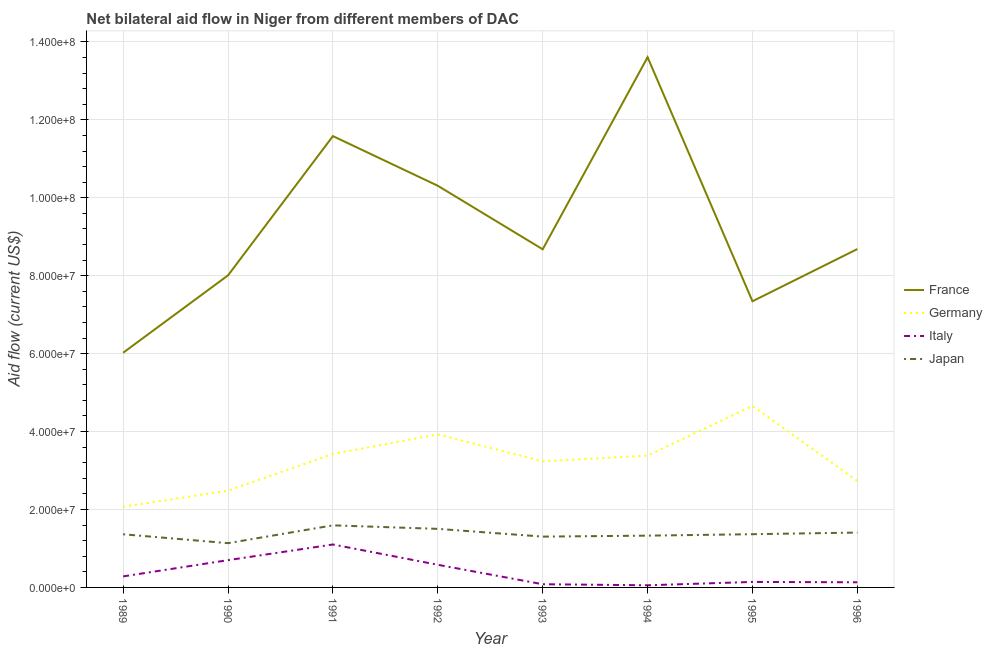Does the line corresponding to amount of aid given by japan intersect with the line corresponding to amount of aid given by france?
Your response must be concise. No. What is the amount of aid given by france in 1995?
Give a very brief answer. 7.34e+07. Across all years, what is the maximum amount of aid given by japan?
Provide a short and direct response. 1.59e+07. Across all years, what is the minimum amount of aid given by france?
Keep it short and to the point. 6.02e+07. In which year was the amount of aid given by france maximum?
Offer a terse response. 1994. What is the total amount of aid given by germany in the graph?
Offer a terse response. 2.59e+08. What is the difference between the amount of aid given by italy in 1989 and that in 1990?
Offer a very short reply. -4.17e+06. What is the difference between the amount of aid given by germany in 1992 and the amount of aid given by france in 1991?
Provide a succinct answer. -7.66e+07. What is the average amount of aid given by france per year?
Give a very brief answer. 9.28e+07. In the year 1992, what is the difference between the amount of aid given by japan and amount of aid given by germany?
Ensure brevity in your answer.  -2.42e+07. In how many years, is the amount of aid given by japan greater than 60000000 US$?
Keep it short and to the point. 0. What is the ratio of the amount of aid given by france in 1989 to that in 1992?
Ensure brevity in your answer.  0.58. Is the amount of aid given by italy in 1992 less than that in 1993?
Give a very brief answer. No. Is the difference between the amount of aid given by japan in 1990 and 1993 greater than the difference between the amount of aid given by germany in 1990 and 1993?
Your answer should be compact. Yes. What is the difference between the highest and the lowest amount of aid given by italy?
Give a very brief answer. 1.05e+07. In how many years, is the amount of aid given by france greater than the average amount of aid given by france taken over all years?
Your answer should be compact. 3. Is the sum of the amount of aid given by france in 1993 and 1996 greater than the maximum amount of aid given by germany across all years?
Give a very brief answer. Yes. Is it the case that in every year, the sum of the amount of aid given by japan and amount of aid given by italy is greater than the sum of amount of aid given by france and amount of aid given by germany?
Your answer should be very brief. No. Is it the case that in every year, the sum of the amount of aid given by france and amount of aid given by germany is greater than the amount of aid given by italy?
Ensure brevity in your answer.  Yes. Is the amount of aid given by france strictly less than the amount of aid given by germany over the years?
Give a very brief answer. No. How many years are there in the graph?
Provide a short and direct response. 8. What is the difference between two consecutive major ticks on the Y-axis?
Your answer should be very brief. 2.00e+07. Are the values on the major ticks of Y-axis written in scientific E-notation?
Your answer should be compact. Yes. Where does the legend appear in the graph?
Provide a succinct answer. Center right. How are the legend labels stacked?
Make the answer very short. Vertical. What is the title of the graph?
Ensure brevity in your answer.  Net bilateral aid flow in Niger from different members of DAC. What is the label or title of the Y-axis?
Your answer should be very brief. Aid flow (current US$). What is the Aid flow (current US$) of France in 1989?
Provide a short and direct response. 6.02e+07. What is the Aid flow (current US$) in Germany in 1989?
Provide a succinct answer. 2.07e+07. What is the Aid flow (current US$) of Italy in 1989?
Provide a succinct answer. 2.83e+06. What is the Aid flow (current US$) of Japan in 1989?
Offer a terse response. 1.36e+07. What is the Aid flow (current US$) in France in 1990?
Your response must be concise. 8.01e+07. What is the Aid flow (current US$) of Germany in 1990?
Keep it short and to the point. 2.48e+07. What is the Aid flow (current US$) of Italy in 1990?
Give a very brief answer. 7.00e+06. What is the Aid flow (current US$) of Japan in 1990?
Make the answer very short. 1.14e+07. What is the Aid flow (current US$) of France in 1991?
Provide a short and direct response. 1.16e+08. What is the Aid flow (current US$) of Germany in 1991?
Offer a very short reply. 3.43e+07. What is the Aid flow (current US$) in Italy in 1991?
Provide a succinct answer. 1.10e+07. What is the Aid flow (current US$) in Japan in 1991?
Offer a very short reply. 1.59e+07. What is the Aid flow (current US$) in France in 1992?
Keep it short and to the point. 1.03e+08. What is the Aid flow (current US$) of Germany in 1992?
Provide a succinct answer. 3.93e+07. What is the Aid flow (current US$) in Italy in 1992?
Give a very brief answer. 5.81e+06. What is the Aid flow (current US$) in Japan in 1992?
Offer a terse response. 1.50e+07. What is the Aid flow (current US$) of France in 1993?
Offer a terse response. 8.68e+07. What is the Aid flow (current US$) of Germany in 1993?
Offer a terse response. 3.24e+07. What is the Aid flow (current US$) of Italy in 1993?
Ensure brevity in your answer.  8.20e+05. What is the Aid flow (current US$) in Japan in 1993?
Offer a terse response. 1.30e+07. What is the Aid flow (current US$) in France in 1994?
Your answer should be very brief. 1.36e+08. What is the Aid flow (current US$) of Germany in 1994?
Keep it short and to the point. 3.38e+07. What is the Aid flow (current US$) in Japan in 1994?
Your response must be concise. 1.33e+07. What is the Aid flow (current US$) in France in 1995?
Ensure brevity in your answer.  7.34e+07. What is the Aid flow (current US$) of Germany in 1995?
Your answer should be very brief. 4.66e+07. What is the Aid flow (current US$) in Italy in 1995?
Your answer should be very brief. 1.41e+06. What is the Aid flow (current US$) in Japan in 1995?
Your response must be concise. 1.37e+07. What is the Aid flow (current US$) in France in 1996?
Provide a short and direct response. 8.68e+07. What is the Aid flow (current US$) of Germany in 1996?
Offer a terse response. 2.73e+07. What is the Aid flow (current US$) in Italy in 1996?
Make the answer very short. 1.32e+06. What is the Aid flow (current US$) of Japan in 1996?
Make the answer very short. 1.41e+07. Across all years, what is the maximum Aid flow (current US$) of France?
Your response must be concise. 1.36e+08. Across all years, what is the maximum Aid flow (current US$) in Germany?
Your answer should be compact. 4.66e+07. Across all years, what is the maximum Aid flow (current US$) in Italy?
Give a very brief answer. 1.10e+07. Across all years, what is the maximum Aid flow (current US$) in Japan?
Your response must be concise. 1.59e+07. Across all years, what is the minimum Aid flow (current US$) in France?
Give a very brief answer. 6.02e+07. Across all years, what is the minimum Aid flow (current US$) of Germany?
Provide a succinct answer. 2.07e+07. Across all years, what is the minimum Aid flow (current US$) of Italy?
Your answer should be compact. 5.50e+05. Across all years, what is the minimum Aid flow (current US$) of Japan?
Keep it short and to the point. 1.14e+07. What is the total Aid flow (current US$) of France in the graph?
Your answer should be very brief. 7.42e+08. What is the total Aid flow (current US$) of Germany in the graph?
Make the answer very short. 2.59e+08. What is the total Aid flow (current US$) of Italy in the graph?
Your answer should be very brief. 3.08e+07. What is the total Aid flow (current US$) of Japan in the graph?
Your response must be concise. 1.10e+08. What is the difference between the Aid flow (current US$) in France in 1989 and that in 1990?
Provide a succinct answer. -1.99e+07. What is the difference between the Aid flow (current US$) in Germany in 1989 and that in 1990?
Your response must be concise. -4.14e+06. What is the difference between the Aid flow (current US$) in Italy in 1989 and that in 1990?
Offer a terse response. -4.17e+06. What is the difference between the Aid flow (current US$) of Japan in 1989 and that in 1990?
Ensure brevity in your answer.  2.28e+06. What is the difference between the Aid flow (current US$) of France in 1989 and that in 1991?
Your answer should be compact. -5.56e+07. What is the difference between the Aid flow (current US$) of Germany in 1989 and that in 1991?
Ensure brevity in your answer.  -1.36e+07. What is the difference between the Aid flow (current US$) of Italy in 1989 and that in 1991?
Give a very brief answer. -8.19e+06. What is the difference between the Aid flow (current US$) in Japan in 1989 and that in 1991?
Keep it short and to the point. -2.29e+06. What is the difference between the Aid flow (current US$) in France in 1989 and that in 1992?
Your answer should be very brief. -4.28e+07. What is the difference between the Aid flow (current US$) in Germany in 1989 and that in 1992?
Offer a terse response. -1.86e+07. What is the difference between the Aid flow (current US$) in Italy in 1989 and that in 1992?
Your answer should be very brief. -2.98e+06. What is the difference between the Aid flow (current US$) of Japan in 1989 and that in 1992?
Offer a very short reply. -1.39e+06. What is the difference between the Aid flow (current US$) in France in 1989 and that in 1993?
Your response must be concise. -2.66e+07. What is the difference between the Aid flow (current US$) of Germany in 1989 and that in 1993?
Make the answer very short. -1.17e+07. What is the difference between the Aid flow (current US$) in Italy in 1989 and that in 1993?
Offer a very short reply. 2.01e+06. What is the difference between the Aid flow (current US$) of Japan in 1989 and that in 1993?
Provide a short and direct response. 6.00e+05. What is the difference between the Aid flow (current US$) in France in 1989 and that in 1994?
Offer a very short reply. -7.58e+07. What is the difference between the Aid flow (current US$) in Germany in 1989 and that in 1994?
Your response must be concise. -1.31e+07. What is the difference between the Aid flow (current US$) of Italy in 1989 and that in 1994?
Make the answer very short. 2.28e+06. What is the difference between the Aid flow (current US$) in Japan in 1989 and that in 1994?
Your answer should be compact. 3.50e+05. What is the difference between the Aid flow (current US$) in France in 1989 and that in 1995?
Keep it short and to the point. -1.32e+07. What is the difference between the Aid flow (current US$) in Germany in 1989 and that in 1995?
Give a very brief answer. -2.59e+07. What is the difference between the Aid flow (current US$) of Italy in 1989 and that in 1995?
Give a very brief answer. 1.42e+06. What is the difference between the Aid flow (current US$) in Japan in 1989 and that in 1995?
Provide a short and direct response. -2.00e+04. What is the difference between the Aid flow (current US$) of France in 1989 and that in 1996?
Keep it short and to the point. -2.66e+07. What is the difference between the Aid flow (current US$) in Germany in 1989 and that in 1996?
Offer a terse response. -6.61e+06. What is the difference between the Aid flow (current US$) of Italy in 1989 and that in 1996?
Offer a very short reply. 1.51e+06. What is the difference between the Aid flow (current US$) in Japan in 1989 and that in 1996?
Provide a succinct answer. -4.40e+05. What is the difference between the Aid flow (current US$) of France in 1990 and that in 1991?
Ensure brevity in your answer.  -3.57e+07. What is the difference between the Aid flow (current US$) of Germany in 1990 and that in 1991?
Provide a succinct answer. -9.42e+06. What is the difference between the Aid flow (current US$) in Italy in 1990 and that in 1991?
Provide a succinct answer. -4.02e+06. What is the difference between the Aid flow (current US$) of Japan in 1990 and that in 1991?
Provide a succinct answer. -4.57e+06. What is the difference between the Aid flow (current US$) of France in 1990 and that in 1992?
Give a very brief answer. -2.30e+07. What is the difference between the Aid flow (current US$) in Germany in 1990 and that in 1992?
Keep it short and to the point. -1.44e+07. What is the difference between the Aid flow (current US$) of Italy in 1990 and that in 1992?
Your answer should be very brief. 1.19e+06. What is the difference between the Aid flow (current US$) of Japan in 1990 and that in 1992?
Provide a short and direct response. -3.67e+06. What is the difference between the Aid flow (current US$) in France in 1990 and that in 1993?
Make the answer very short. -6.69e+06. What is the difference between the Aid flow (current US$) in Germany in 1990 and that in 1993?
Your answer should be compact. -7.53e+06. What is the difference between the Aid flow (current US$) of Italy in 1990 and that in 1993?
Your answer should be very brief. 6.18e+06. What is the difference between the Aid flow (current US$) in Japan in 1990 and that in 1993?
Provide a succinct answer. -1.68e+06. What is the difference between the Aid flow (current US$) of France in 1990 and that in 1994?
Provide a succinct answer. -5.60e+07. What is the difference between the Aid flow (current US$) of Germany in 1990 and that in 1994?
Offer a terse response. -8.99e+06. What is the difference between the Aid flow (current US$) in Italy in 1990 and that in 1994?
Your response must be concise. 6.45e+06. What is the difference between the Aid flow (current US$) in Japan in 1990 and that in 1994?
Ensure brevity in your answer.  -1.93e+06. What is the difference between the Aid flow (current US$) of France in 1990 and that in 1995?
Offer a very short reply. 6.65e+06. What is the difference between the Aid flow (current US$) in Germany in 1990 and that in 1995?
Keep it short and to the point. -2.17e+07. What is the difference between the Aid flow (current US$) of Italy in 1990 and that in 1995?
Make the answer very short. 5.59e+06. What is the difference between the Aid flow (current US$) in Japan in 1990 and that in 1995?
Give a very brief answer. -2.30e+06. What is the difference between the Aid flow (current US$) in France in 1990 and that in 1996?
Offer a very short reply. -6.75e+06. What is the difference between the Aid flow (current US$) in Germany in 1990 and that in 1996?
Offer a terse response. -2.47e+06. What is the difference between the Aid flow (current US$) in Italy in 1990 and that in 1996?
Make the answer very short. 5.68e+06. What is the difference between the Aid flow (current US$) in Japan in 1990 and that in 1996?
Offer a very short reply. -2.72e+06. What is the difference between the Aid flow (current US$) in France in 1991 and that in 1992?
Provide a short and direct response. 1.28e+07. What is the difference between the Aid flow (current US$) of Germany in 1991 and that in 1992?
Your answer should be very brief. -5.01e+06. What is the difference between the Aid flow (current US$) of Italy in 1991 and that in 1992?
Your answer should be compact. 5.21e+06. What is the difference between the Aid flow (current US$) of France in 1991 and that in 1993?
Make the answer very short. 2.90e+07. What is the difference between the Aid flow (current US$) of Germany in 1991 and that in 1993?
Provide a short and direct response. 1.89e+06. What is the difference between the Aid flow (current US$) in Italy in 1991 and that in 1993?
Offer a terse response. 1.02e+07. What is the difference between the Aid flow (current US$) in Japan in 1991 and that in 1993?
Your response must be concise. 2.89e+06. What is the difference between the Aid flow (current US$) in France in 1991 and that in 1994?
Offer a terse response. -2.02e+07. What is the difference between the Aid flow (current US$) in Italy in 1991 and that in 1994?
Give a very brief answer. 1.05e+07. What is the difference between the Aid flow (current US$) of Japan in 1991 and that in 1994?
Make the answer very short. 2.64e+06. What is the difference between the Aid flow (current US$) in France in 1991 and that in 1995?
Offer a terse response. 4.24e+07. What is the difference between the Aid flow (current US$) of Germany in 1991 and that in 1995?
Your answer should be compact. -1.23e+07. What is the difference between the Aid flow (current US$) in Italy in 1991 and that in 1995?
Provide a short and direct response. 9.61e+06. What is the difference between the Aid flow (current US$) in Japan in 1991 and that in 1995?
Offer a very short reply. 2.27e+06. What is the difference between the Aid flow (current US$) of France in 1991 and that in 1996?
Your answer should be very brief. 2.90e+07. What is the difference between the Aid flow (current US$) of Germany in 1991 and that in 1996?
Provide a succinct answer. 6.95e+06. What is the difference between the Aid flow (current US$) of Italy in 1991 and that in 1996?
Keep it short and to the point. 9.70e+06. What is the difference between the Aid flow (current US$) of Japan in 1991 and that in 1996?
Make the answer very short. 1.85e+06. What is the difference between the Aid flow (current US$) in France in 1992 and that in 1993?
Your answer should be very brief. 1.63e+07. What is the difference between the Aid flow (current US$) of Germany in 1992 and that in 1993?
Your answer should be compact. 6.90e+06. What is the difference between the Aid flow (current US$) of Italy in 1992 and that in 1993?
Keep it short and to the point. 4.99e+06. What is the difference between the Aid flow (current US$) of Japan in 1992 and that in 1993?
Your response must be concise. 1.99e+06. What is the difference between the Aid flow (current US$) in France in 1992 and that in 1994?
Ensure brevity in your answer.  -3.30e+07. What is the difference between the Aid flow (current US$) in Germany in 1992 and that in 1994?
Your answer should be compact. 5.44e+06. What is the difference between the Aid flow (current US$) of Italy in 1992 and that in 1994?
Give a very brief answer. 5.26e+06. What is the difference between the Aid flow (current US$) of Japan in 1992 and that in 1994?
Ensure brevity in your answer.  1.74e+06. What is the difference between the Aid flow (current US$) of France in 1992 and that in 1995?
Offer a terse response. 2.96e+07. What is the difference between the Aid flow (current US$) in Germany in 1992 and that in 1995?
Your answer should be compact. -7.31e+06. What is the difference between the Aid flow (current US$) in Italy in 1992 and that in 1995?
Offer a very short reply. 4.40e+06. What is the difference between the Aid flow (current US$) of Japan in 1992 and that in 1995?
Your response must be concise. 1.37e+06. What is the difference between the Aid flow (current US$) in France in 1992 and that in 1996?
Offer a very short reply. 1.62e+07. What is the difference between the Aid flow (current US$) of Germany in 1992 and that in 1996?
Your response must be concise. 1.20e+07. What is the difference between the Aid flow (current US$) of Italy in 1992 and that in 1996?
Provide a short and direct response. 4.49e+06. What is the difference between the Aid flow (current US$) of Japan in 1992 and that in 1996?
Give a very brief answer. 9.50e+05. What is the difference between the Aid flow (current US$) in France in 1993 and that in 1994?
Provide a succinct answer. -4.93e+07. What is the difference between the Aid flow (current US$) of Germany in 1993 and that in 1994?
Your answer should be compact. -1.46e+06. What is the difference between the Aid flow (current US$) of Italy in 1993 and that in 1994?
Your response must be concise. 2.70e+05. What is the difference between the Aid flow (current US$) in Japan in 1993 and that in 1994?
Your response must be concise. -2.50e+05. What is the difference between the Aid flow (current US$) of France in 1993 and that in 1995?
Provide a succinct answer. 1.33e+07. What is the difference between the Aid flow (current US$) of Germany in 1993 and that in 1995?
Provide a short and direct response. -1.42e+07. What is the difference between the Aid flow (current US$) of Italy in 1993 and that in 1995?
Provide a short and direct response. -5.90e+05. What is the difference between the Aid flow (current US$) of Japan in 1993 and that in 1995?
Provide a short and direct response. -6.20e+05. What is the difference between the Aid flow (current US$) in Germany in 1993 and that in 1996?
Provide a short and direct response. 5.06e+06. What is the difference between the Aid flow (current US$) of Italy in 1993 and that in 1996?
Offer a terse response. -5.00e+05. What is the difference between the Aid flow (current US$) of Japan in 1993 and that in 1996?
Provide a short and direct response. -1.04e+06. What is the difference between the Aid flow (current US$) in France in 1994 and that in 1995?
Your response must be concise. 6.26e+07. What is the difference between the Aid flow (current US$) of Germany in 1994 and that in 1995?
Keep it short and to the point. -1.28e+07. What is the difference between the Aid flow (current US$) in Italy in 1994 and that in 1995?
Give a very brief answer. -8.60e+05. What is the difference between the Aid flow (current US$) in Japan in 1994 and that in 1995?
Your answer should be very brief. -3.70e+05. What is the difference between the Aid flow (current US$) of France in 1994 and that in 1996?
Keep it short and to the point. 4.92e+07. What is the difference between the Aid flow (current US$) in Germany in 1994 and that in 1996?
Keep it short and to the point. 6.52e+06. What is the difference between the Aid flow (current US$) of Italy in 1994 and that in 1996?
Keep it short and to the point. -7.70e+05. What is the difference between the Aid flow (current US$) of Japan in 1994 and that in 1996?
Provide a succinct answer. -7.90e+05. What is the difference between the Aid flow (current US$) of France in 1995 and that in 1996?
Give a very brief answer. -1.34e+07. What is the difference between the Aid flow (current US$) in Germany in 1995 and that in 1996?
Offer a very short reply. 1.93e+07. What is the difference between the Aid flow (current US$) in Italy in 1995 and that in 1996?
Your answer should be very brief. 9.00e+04. What is the difference between the Aid flow (current US$) in Japan in 1995 and that in 1996?
Offer a terse response. -4.20e+05. What is the difference between the Aid flow (current US$) in France in 1989 and the Aid flow (current US$) in Germany in 1990?
Offer a very short reply. 3.54e+07. What is the difference between the Aid flow (current US$) in France in 1989 and the Aid flow (current US$) in Italy in 1990?
Your answer should be very brief. 5.32e+07. What is the difference between the Aid flow (current US$) in France in 1989 and the Aid flow (current US$) in Japan in 1990?
Ensure brevity in your answer.  4.89e+07. What is the difference between the Aid flow (current US$) in Germany in 1989 and the Aid flow (current US$) in Italy in 1990?
Ensure brevity in your answer.  1.37e+07. What is the difference between the Aid flow (current US$) of Germany in 1989 and the Aid flow (current US$) of Japan in 1990?
Your response must be concise. 9.34e+06. What is the difference between the Aid flow (current US$) in Italy in 1989 and the Aid flow (current US$) in Japan in 1990?
Give a very brief answer. -8.53e+06. What is the difference between the Aid flow (current US$) of France in 1989 and the Aid flow (current US$) of Germany in 1991?
Offer a terse response. 2.60e+07. What is the difference between the Aid flow (current US$) in France in 1989 and the Aid flow (current US$) in Italy in 1991?
Ensure brevity in your answer.  4.92e+07. What is the difference between the Aid flow (current US$) of France in 1989 and the Aid flow (current US$) of Japan in 1991?
Your answer should be very brief. 4.43e+07. What is the difference between the Aid flow (current US$) in Germany in 1989 and the Aid flow (current US$) in Italy in 1991?
Give a very brief answer. 9.68e+06. What is the difference between the Aid flow (current US$) of Germany in 1989 and the Aid flow (current US$) of Japan in 1991?
Provide a succinct answer. 4.77e+06. What is the difference between the Aid flow (current US$) of Italy in 1989 and the Aid flow (current US$) of Japan in 1991?
Offer a very short reply. -1.31e+07. What is the difference between the Aid flow (current US$) of France in 1989 and the Aid flow (current US$) of Germany in 1992?
Keep it short and to the point. 2.10e+07. What is the difference between the Aid flow (current US$) in France in 1989 and the Aid flow (current US$) in Italy in 1992?
Provide a short and direct response. 5.44e+07. What is the difference between the Aid flow (current US$) of France in 1989 and the Aid flow (current US$) of Japan in 1992?
Your response must be concise. 4.52e+07. What is the difference between the Aid flow (current US$) of Germany in 1989 and the Aid flow (current US$) of Italy in 1992?
Ensure brevity in your answer.  1.49e+07. What is the difference between the Aid flow (current US$) of Germany in 1989 and the Aid flow (current US$) of Japan in 1992?
Give a very brief answer. 5.67e+06. What is the difference between the Aid flow (current US$) of Italy in 1989 and the Aid flow (current US$) of Japan in 1992?
Make the answer very short. -1.22e+07. What is the difference between the Aid flow (current US$) of France in 1989 and the Aid flow (current US$) of Germany in 1993?
Your response must be concise. 2.79e+07. What is the difference between the Aid flow (current US$) of France in 1989 and the Aid flow (current US$) of Italy in 1993?
Your answer should be compact. 5.94e+07. What is the difference between the Aid flow (current US$) in France in 1989 and the Aid flow (current US$) in Japan in 1993?
Offer a terse response. 4.72e+07. What is the difference between the Aid flow (current US$) in Germany in 1989 and the Aid flow (current US$) in Italy in 1993?
Your response must be concise. 1.99e+07. What is the difference between the Aid flow (current US$) in Germany in 1989 and the Aid flow (current US$) in Japan in 1993?
Your response must be concise. 7.66e+06. What is the difference between the Aid flow (current US$) in Italy in 1989 and the Aid flow (current US$) in Japan in 1993?
Your response must be concise. -1.02e+07. What is the difference between the Aid flow (current US$) in France in 1989 and the Aid flow (current US$) in Germany in 1994?
Your answer should be very brief. 2.64e+07. What is the difference between the Aid flow (current US$) in France in 1989 and the Aid flow (current US$) in Italy in 1994?
Your answer should be very brief. 5.97e+07. What is the difference between the Aid flow (current US$) of France in 1989 and the Aid flow (current US$) of Japan in 1994?
Offer a terse response. 4.69e+07. What is the difference between the Aid flow (current US$) of Germany in 1989 and the Aid flow (current US$) of Italy in 1994?
Your answer should be very brief. 2.02e+07. What is the difference between the Aid flow (current US$) of Germany in 1989 and the Aid flow (current US$) of Japan in 1994?
Your response must be concise. 7.41e+06. What is the difference between the Aid flow (current US$) in Italy in 1989 and the Aid flow (current US$) in Japan in 1994?
Your response must be concise. -1.05e+07. What is the difference between the Aid flow (current US$) of France in 1989 and the Aid flow (current US$) of Germany in 1995?
Provide a succinct answer. 1.36e+07. What is the difference between the Aid flow (current US$) of France in 1989 and the Aid flow (current US$) of Italy in 1995?
Ensure brevity in your answer.  5.88e+07. What is the difference between the Aid flow (current US$) of France in 1989 and the Aid flow (current US$) of Japan in 1995?
Keep it short and to the point. 4.66e+07. What is the difference between the Aid flow (current US$) of Germany in 1989 and the Aid flow (current US$) of Italy in 1995?
Give a very brief answer. 1.93e+07. What is the difference between the Aid flow (current US$) of Germany in 1989 and the Aid flow (current US$) of Japan in 1995?
Offer a terse response. 7.04e+06. What is the difference between the Aid flow (current US$) of Italy in 1989 and the Aid flow (current US$) of Japan in 1995?
Ensure brevity in your answer.  -1.08e+07. What is the difference between the Aid flow (current US$) of France in 1989 and the Aid flow (current US$) of Germany in 1996?
Make the answer very short. 3.29e+07. What is the difference between the Aid flow (current US$) in France in 1989 and the Aid flow (current US$) in Italy in 1996?
Offer a very short reply. 5.89e+07. What is the difference between the Aid flow (current US$) of France in 1989 and the Aid flow (current US$) of Japan in 1996?
Give a very brief answer. 4.62e+07. What is the difference between the Aid flow (current US$) in Germany in 1989 and the Aid flow (current US$) in Italy in 1996?
Your answer should be compact. 1.94e+07. What is the difference between the Aid flow (current US$) of Germany in 1989 and the Aid flow (current US$) of Japan in 1996?
Provide a short and direct response. 6.62e+06. What is the difference between the Aid flow (current US$) in Italy in 1989 and the Aid flow (current US$) in Japan in 1996?
Your response must be concise. -1.12e+07. What is the difference between the Aid flow (current US$) of France in 1990 and the Aid flow (current US$) of Germany in 1991?
Ensure brevity in your answer.  4.58e+07. What is the difference between the Aid flow (current US$) of France in 1990 and the Aid flow (current US$) of Italy in 1991?
Make the answer very short. 6.91e+07. What is the difference between the Aid flow (current US$) in France in 1990 and the Aid flow (current US$) in Japan in 1991?
Your answer should be compact. 6.42e+07. What is the difference between the Aid flow (current US$) in Germany in 1990 and the Aid flow (current US$) in Italy in 1991?
Your response must be concise. 1.38e+07. What is the difference between the Aid flow (current US$) of Germany in 1990 and the Aid flow (current US$) of Japan in 1991?
Keep it short and to the point. 8.91e+06. What is the difference between the Aid flow (current US$) in Italy in 1990 and the Aid flow (current US$) in Japan in 1991?
Your response must be concise. -8.93e+06. What is the difference between the Aid flow (current US$) in France in 1990 and the Aid flow (current US$) in Germany in 1992?
Keep it short and to the point. 4.08e+07. What is the difference between the Aid flow (current US$) in France in 1990 and the Aid flow (current US$) in Italy in 1992?
Offer a very short reply. 7.43e+07. What is the difference between the Aid flow (current US$) in France in 1990 and the Aid flow (current US$) in Japan in 1992?
Make the answer very short. 6.51e+07. What is the difference between the Aid flow (current US$) in Germany in 1990 and the Aid flow (current US$) in Italy in 1992?
Your response must be concise. 1.90e+07. What is the difference between the Aid flow (current US$) in Germany in 1990 and the Aid flow (current US$) in Japan in 1992?
Ensure brevity in your answer.  9.81e+06. What is the difference between the Aid flow (current US$) of Italy in 1990 and the Aid flow (current US$) of Japan in 1992?
Keep it short and to the point. -8.03e+06. What is the difference between the Aid flow (current US$) in France in 1990 and the Aid flow (current US$) in Germany in 1993?
Offer a very short reply. 4.77e+07. What is the difference between the Aid flow (current US$) of France in 1990 and the Aid flow (current US$) of Italy in 1993?
Ensure brevity in your answer.  7.93e+07. What is the difference between the Aid flow (current US$) in France in 1990 and the Aid flow (current US$) in Japan in 1993?
Your answer should be very brief. 6.70e+07. What is the difference between the Aid flow (current US$) in Germany in 1990 and the Aid flow (current US$) in Italy in 1993?
Offer a very short reply. 2.40e+07. What is the difference between the Aid flow (current US$) in Germany in 1990 and the Aid flow (current US$) in Japan in 1993?
Offer a terse response. 1.18e+07. What is the difference between the Aid flow (current US$) in Italy in 1990 and the Aid flow (current US$) in Japan in 1993?
Provide a succinct answer. -6.04e+06. What is the difference between the Aid flow (current US$) of France in 1990 and the Aid flow (current US$) of Germany in 1994?
Ensure brevity in your answer.  4.63e+07. What is the difference between the Aid flow (current US$) of France in 1990 and the Aid flow (current US$) of Italy in 1994?
Provide a succinct answer. 7.95e+07. What is the difference between the Aid flow (current US$) in France in 1990 and the Aid flow (current US$) in Japan in 1994?
Provide a succinct answer. 6.68e+07. What is the difference between the Aid flow (current US$) in Germany in 1990 and the Aid flow (current US$) in Italy in 1994?
Your answer should be compact. 2.43e+07. What is the difference between the Aid flow (current US$) in Germany in 1990 and the Aid flow (current US$) in Japan in 1994?
Provide a succinct answer. 1.16e+07. What is the difference between the Aid flow (current US$) in Italy in 1990 and the Aid flow (current US$) in Japan in 1994?
Provide a succinct answer. -6.29e+06. What is the difference between the Aid flow (current US$) of France in 1990 and the Aid flow (current US$) of Germany in 1995?
Give a very brief answer. 3.35e+07. What is the difference between the Aid flow (current US$) in France in 1990 and the Aid flow (current US$) in Italy in 1995?
Provide a short and direct response. 7.87e+07. What is the difference between the Aid flow (current US$) of France in 1990 and the Aid flow (current US$) of Japan in 1995?
Your answer should be compact. 6.64e+07. What is the difference between the Aid flow (current US$) of Germany in 1990 and the Aid flow (current US$) of Italy in 1995?
Your response must be concise. 2.34e+07. What is the difference between the Aid flow (current US$) in Germany in 1990 and the Aid flow (current US$) in Japan in 1995?
Your answer should be very brief. 1.12e+07. What is the difference between the Aid flow (current US$) in Italy in 1990 and the Aid flow (current US$) in Japan in 1995?
Ensure brevity in your answer.  -6.66e+06. What is the difference between the Aid flow (current US$) of France in 1990 and the Aid flow (current US$) of Germany in 1996?
Provide a succinct answer. 5.28e+07. What is the difference between the Aid flow (current US$) of France in 1990 and the Aid flow (current US$) of Italy in 1996?
Offer a very short reply. 7.88e+07. What is the difference between the Aid flow (current US$) of France in 1990 and the Aid flow (current US$) of Japan in 1996?
Give a very brief answer. 6.60e+07. What is the difference between the Aid flow (current US$) of Germany in 1990 and the Aid flow (current US$) of Italy in 1996?
Provide a succinct answer. 2.35e+07. What is the difference between the Aid flow (current US$) in Germany in 1990 and the Aid flow (current US$) in Japan in 1996?
Your answer should be compact. 1.08e+07. What is the difference between the Aid flow (current US$) in Italy in 1990 and the Aid flow (current US$) in Japan in 1996?
Give a very brief answer. -7.08e+06. What is the difference between the Aid flow (current US$) of France in 1991 and the Aid flow (current US$) of Germany in 1992?
Your answer should be compact. 7.66e+07. What is the difference between the Aid flow (current US$) of France in 1991 and the Aid flow (current US$) of Italy in 1992?
Offer a very short reply. 1.10e+08. What is the difference between the Aid flow (current US$) of France in 1991 and the Aid flow (current US$) of Japan in 1992?
Provide a succinct answer. 1.01e+08. What is the difference between the Aid flow (current US$) in Germany in 1991 and the Aid flow (current US$) in Italy in 1992?
Keep it short and to the point. 2.84e+07. What is the difference between the Aid flow (current US$) in Germany in 1991 and the Aid flow (current US$) in Japan in 1992?
Keep it short and to the point. 1.92e+07. What is the difference between the Aid flow (current US$) of Italy in 1991 and the Aid flow (current US$) of Japan in 1992?
Offer a terse response. -4.01e+06. What is the difference between the Aid flow (current US$) in France in 1991 and the Aid flow (current US$) in Germany in 1993?
Your answer should be compact. 8.35e+07. What is the difference between the Aid flow (current US$) of France in 1991 and the Aid flow (current US$) of Italy in 1993?
Offer a terse response. 1.15e+08. What is the difference between the Aid flow (current US$) of France in 1991 and the Aid flow (current US$) of Japan in 1993?
Ensure brevity in your answer.  1.03e+08. What is the difference between the Aid flow (current US$) of Germany in 1991 and the Aid flow (current US$) of Italy in 1993?
Your answer should be very brief. 3.34e+07. What is the difference between the Aid flow (current US$) in Germany in 1991 and the Aid flow (current US$) in Japan in 1993?
Provide a succinct answer. 2.12e+07. What is the difference between the Aid flow (current US$) in Italy in 1991 and the Aid flow (current US$) in Japan in 1993?
Your answer should be compact. -2.02e+06. What is the difference between the Aid flow (current US$) of France in 1991 and the Aid flow (current US$) of Germany in 1994?
Ensure brevity in your answer.  8.20e+07. What is the difference between the Aid flow (current US$) of France in 1991 and the Aid flow (current US$) of Italy in 1994?
Make the answer very short. 1.15e+08. What is the difference between the Aid flow (current US$) of France in 1991 and the Aid flow (current US$) of Japan in 1994?
Offer a very short reply. 1.03e+08. What is the difference between the Aid flow (current US$) of Germany in 1991 and the Aid flow (current US$) of Italy in 1994?
Provide a short and direct response. 3.37e+07. What is the difference between the Aid flow (current US$) of Germany in 1991 and the Aid flow (current US$) of Japan in 1994?
Your answer should be compact. 2.10e+07. What is the difference between the Aid flow (current US$) in Italy in 1991 and the Aid flow (current US$) in Japan in 1994?
Keep it short and to the point. -2.27e+06. What is the difference between the Aid flow (current US$) in France in 1991 and the Aid flow (current US$) in Germany in 1995?
Keep it short and to the point. 6.92e+07. What is the difference between the Aid flow (current US$) in France in 1991 and the Aid flow (current US$) in Italy in 1995?
Ensure brevity in your answer.  1.14e+08. What is the difference between the Aid flow (current US$) of France in 1991 and the Aid flow (current US$) of Japan in 1995?
Provide a succinct answer. 1.02e+08. What is the difference between the Aid flow (current US$) in Germany in 1991 and the Aid flow (current US$) in Italy in 1995?
Offer a very short reply. 3.28e+07. What is the difference between the Aid flow (current US$) of Germany in 1991 and the Aid flow (current US$) of Japan in 1995?
Make the answer very short. 2.06e+07. What is the difference between the Aid flow (current US$) in Italy in 1991 and the Aid flow (current US$) in Japan in 1995?
Offer a terse response. -2.64e+06. What is the difference between the Aid flow (current US$) of France in 1991 and the Aid flow (current US$) of Germany in 1996?
Give a very brief answer. 8.85e+07. What is the difference between the Aid flow (current US$) of France in 1991 and the Aid flow (current US$) of Italy in 1996?
Give a very brief answer. 1.15e+08. What is the difference between the Aid flow (current US$) of France in 1991 and the Aid flow (current US$) of Japan in 1996?
Provide a succinct answer. 1.02e+08. What is the difference between the Aid flow (current US$) in Germany in 1991 and the Aid flow (current US$) in Italy in 1996?
Ensure brevity in your answer.  3.29e+07. What is the difference between the Aid flow (current US$) in Germany in 1991 and the Aid flow (current US$) in Japan in 1996?
Offer a very short reply. 2.02e+07. What is the difference between the Aid flow (current US$) of Italy in 1991 and the Aid flow (current US$) of Japan in 1996?
Provide a succinct answer. -3.06e+06. What is the difference between the Aid flow (current US$) in France in 1992 and the Aid flow (current US$) in Germany in 1993?
Your answer should be very brief. 7.07e+07. What is the difference between the Aid flow (current US$) of France in 1992 and the Aid flow (current US$) of Italy in 1993?
Offer a very short reply. 1.02e+08. What is the difference between the Aid flow (current US$) of France in 1992 and the Aid flow (current US$) of Japan in 1993?
Your answer should be very brief. 9.00e+07. What is the difference between the Aid flow (current US$) in Germany in 1992 and the Aid flow (current US$) in Italy in 1993?
Your answer should be compact. 3.84e+07. What is the difference between the Aid flow (current US$) in Germany in 1992 and the Aid flow (current US$) in Japan in 1993?
Ensure brevity in your answer.  2.62e+07. What is the difference between the Aid flow (current US$) in Italy in 1992 and the Aid flow (current US$) in Japan in 1993?
Make the answer very short. -7.23e+06. What is the difference between the Aid flow (current US$) in France in 1992 and the Aid flow (current US$) in Germany in 1994?
Make the answer very short. 6.92e+07. What is the difference between the Aid flow (current US$) of France in 1992 and the Aid flow (current US$) of Italy in 1994?
Offer a very short reply. 1.03e+08. What is the difference between the Aid flow (current US$) in France in 1992 and the Aid flow (current US$) in Japan in 1994?
Your answer should be compact. 8.98e+07. What is the difference between the Aid flow (current US$) in Germany in 1992 and the Aid flow (current US$) in Italy in 1994?
Your response must be concise. 3.87e+07. What is the difference between the Aid flow (current US$) in Germany in 1992 and the Aid flow (current US$) in Japan in 1994?
Provide a short and direct response. 2.60e+07. What is the difference between the Aid flow (current US$) in Italy in 1992 and the Aid flow (current US$) in Japan in 1994?
Your answer should be very brief. -7.48e+06. What is the difference between the Aid flow (current US$) in France in 1992 and the Aid flow (current US$) in Germany in 1995?
Give a very brief answer. 5.65e+07. What is the difference between the Aid flow (current US$) of France in 1992 and the Aid flow (current US$) of Italy in 1995?
Offer a terse response. 1.02e+08. What is the difference between the Aid flow (current US$) in France in 1992 and the Aid flow (current US$) in Japan in 1995?
Keep it short and to the point. 8.94e+07. What is the difference between the Aid flow (current US$) of Germany in 1992 and the Aid flow (current US$) of Italy in 1995?
Offer a very short reply. 3.79e+07. What is the difference between the Aid flow (current US$) in Germany in 1992 and the Aid flow (current US$) in Japan in 1995?
Give a very brief answer. 2.56e+07. What is the difference between the Aid flow (current US$) in Italy in 1992 and the Aid flow (current US$) in Japan in 1995?
Your answer should be compact. -7.85e+06. What is the difference between the Aid flow (current US$) in France in 1992 and the Aid flow (current US$) in Germany in 1996?
Ensure brevity in your answer.  7.58e+07. What is the difference between the Aid flow (current US$) of France in 1992 and the Aid flow (current US$) of Italy in 1996?
Offer a very short reply. 1.02e+08. What is the difference between the Aid flow (current US$) of France in 1992 and the Aid flow (current US$) of Japan in 1996?
Ensure brevity in your answer.  8.90e+07. What is the difference between the Aid flow (current US$) in Germany in 1992 and the Aid flow (current US$) in Italy in 1996?
Give a very brief answer. 3.80e+07. What is the difference between the Aid flow (current US$) of Germany in 1992 and the Aid flow (current US$) of Japan in 1996?
Ensure brevity in your answer.  2.52e+07. What is the difference between the Aid flow (current US$) in Italy in 1992 and the Aid flow (current US$) in Japan in 1996?
Provide a short and direct response. -8.27e+06. What is the difference between the Aid flow (current US$) in France in 1993 and the Aid flow (current US$) in Germany in 1994?
Provide a short and direct response. 5.30e+07. What is the difference between the Aid flow (current US$) in France in 1993 and the Aid flow (current US$) in Italy in 1994?
Your response must be concise. 8.62e+07. What is the difference between the Aid flow (current US$) in France in 1993 and the Aid flow (current US$) in Japan in 1994?
Your answer should be compact. 7.35e+07. What is the difference between the Aid flow (current US$) in Germany in 1993 and the Aid flow (current US$) in Italy in 1994?
Offer a terse response. 3.18e+07. What is the difference between the Aid flow (current US$) of Germany in 1993 and the Aid flow (current US$) of Japan in 1994?
Offer a terse response. 1.91e+07. What is the difference between the Aid flow (current US$) in Italy in 1993 and the Aid flow (current US$) in Japan in 1994?
Offer a terse response. -1.25e+07. What is the difference between the Aid flow (current US$) of France in 1993 and the Aid flow (current US$) of Germany in 1995?
Keep it short and to the point. 4.02e+07. What is the difference between the Aid flow (current US$) of France in 1993 and the Aid flow (current US$) of Italy in 1995?
Your answer should be compact. 8.54e+07. What is the difference between the Aid flow (current US$) in France in 1993 and the Aid flow (current US$) in Japan in 1995?
Ensure brevity in your answer.  7.31e+07. What is the difference between the Aid flow (current US$) in Germany in 1993 and the Aid flow (current US$) in Italy in 1995?
Ensure brevity in your answer.  3.10e+07. What is the difference between the Aid flow (current US$) in Germany in 1993 and the Aid flow (current US$) in Japan in 1995?
Ensure brevity in your answer.  1.87e+07. What is the difference between the Aid flow (current US$) in Italy in 1993 and the Aid flow (current US$) in Japan in 1995?
Offer a very short reply. -1.28e+07. What is the difference between the Aid flow (current US$) of France in 1993 and the Aid flow (current US$) of Germany in 1996?
Offer a very short reply. 5.95e+07. What is the difference between the Aid flow (current US$) of France in 1993 and the Aid flow (current US$) of Italy in 1996?
Make the answer very short. 8.55e+07. What is the difference between the Aid flow (current US$) in France in 1993 and the Aid flow (current US$) in Japan in 1996?
Your response must be concise. 7.27e+07. What is the difference between the Aid flow (current US$) of Germany in 1993 and the Aid flow (current US$) of Italy in 1996?
Offer a terse response. 3.10e+07. What is the difference between the Aid flow (current US$) of Germany in 1993 and the Aid flow (current US$) of Japan in 1996?
Keep it short and to the point. 1.83e+07. What is the difference between the Aid flow (current US$) in Italy in 1993 and the Aid flow (current US$) in Japan in 1996?
Give a very brief answer. -1.33e+07. What is the difference between the Aid flow (current US$) in France in 1994 and the Aid flow (current US$) in Germany in 1995?
Your answer should be very brief. 8.95e+07. What is the difference between the Aid flow (current US$) of France in 1994 and the Aid flow (current US$) of Italy in 1995?
Provide a short and direct response. 1.35e+08. What is the difference between the Aid flow (current US$) in France in 1994 and the Aid flow (current US$) in Japan in 1995?
Your answer should be very brief. 1.22e+08. What is the difference between the Aid flow (current US$) of Germany in 1994 and the Aid flow (current US$) of Italy in 1995?
Offer a terse response. 3.24e+07. What is the difference between the Aid flow (current US$) in Germany in 1994 and the Aid flow (current US$) in Japan in 1995?
Your answer should be compact. 2.02e+07. What is the difference between the Aid flow (current US$) of Italy in 1994 and the Aid flow (current US$) of Japan in 1995?
Give a very brief answer. -1.31e+07. What is the difference between the Aid flow (current US$) of France in 1994 and the Aid flow (current US$) of Germany in 1996?
Ensure brevity in your answer.  1.09e+08. What is the difference between the Aid flow (current US$) of France in 1994 and the Aid flow (current US$) of Italy in 1996?
Your response must be concise. 1.35e+08. What is the difference between the Aid flow (current US$) in France in 1994 and the Aid flow (current US$) in Japan in 1996?
Your response must be concise. 1.22e+08. What is the difference between the Aid flow (current US$) of Germany in 1994 and the Aid flow (current US$) of Italy in 1996?
Provide a short and direct response. 3.25e+07. What is the difference between the Aid flow (current US$) of Germany in 1994 and the Aid flow (current US$) of Japan in 1996?
Ensure brevity in your answer.  1.98e+07. What is the difference between the Aid flow (current US$) in Italy in 1994 and the Aid flow (current US$) in Japan in 1996?
Ensure brevity in your answer.  -1.35e+07. What is the difference between the Aid flow (current US$) in France in 1995 and the Aid flow (current US$) in Germany in 1996?
Ensure brevity in your answer.  4.61e+07. What is the difference between the Aid flow (current US$) in France in 1995 and the Aid flow (current US$) in Italy in 1996?
Make the answer very short. 7.21e+07. What is the difference between the Aid flow (current US$) of France in 1995 and the Aid flow (current US$) of Japan in 1996?
Provide a succinct answer. 5.94e+07. What is the difference between the Aid flow (current US$) in Germany in 1995 and the Aid flow (current US$) in Italy in 1996?
Offer a very short reply. 4.53e+07. What is the difference between the Aid flow (current US$) in Germany in 1995 and the Aid flow (current US$) in Japan in 1996?
Provide a succinct answer. 3.25e+07. What is the difference between the Aid flow (current US$) of Italy in 1995 and the Aid flow (current US$) of Japan in 1996?
Give a very brief answer. -1.27e+07. What is the average Aid flow (current US$) in France per year?
Your response must be concise. 9.28e+07. What is the average Aid flow (current US$) in Germany per year?
Make the answer very short. 3.24e+07. What is the average Aid flow (current US$) in Italy per year?
Offer a terse response. 3.84e+06. What is the average Aid flow (current US$) in Japan per year?
Give a very brief answer. 1.38e+07. In the year 1989, what is the difference between the Aid flow (current US$) in France and Aid flow (current US$) in Germany?
Ensure brevity in your answer.  3.95e+07. In the year 1989, what is the difference between the Aid flow (current US$) in France and Aid flow (current US$) in Italy?
Your response must be concise. 5.74e+07. In the year 1989, what is the difference between the Aid flow (current US$) in France and Aid flow (current US$) in Japan?
Your answer should be compact. 4.66e+07. In the year 1989, what is the difference between the Aid flow (current US$) in Germany and Aid flow (current US$) in Italy?
Make the answer very short. 1.79e+07. In the year 1989, what is the difference between the Aid flow (current US$) in Germany and Aid flow (current US$) in Japan?
Make the answer very short. 7.06e+06. In the year 1989, what is the difference between the Aid flow (current US$) of Italy and Aid flow (current US$) of Japan?
Make the answer very short. -1.08e+07. In the year 1990, what is the difference between the Aid flow (current US$) of France and Aid flow (current US$) of Germany?
Give a very brief answer. 5.52e+07. In the year 1990, what is the difference between the Aid flow (current US$) of France and Aid flow (current US$) of Italy?
Offer a very short reply. 7.31e+07. In the year 1990, what is the difference between the Aid flow (current US$) in France and Aid flow (current US$) in Japan?
Ensure brevity in your answer.  6.87e+07. In the year 1990, what is the difference between the Aid flow (current US$) of Germany and Aid flow (current US$) of Italy?
Provide a succinct answer. 1.78e+07. In the year 1990, what is the difference between the Aid flow (current US$) of Germany and Aid flow (current US$) of Japan?
Provide a succinct answer. 1.35e+07. In the year 1990, what is the difference between the Aid flow (current US$) in Italy and Aid flow (current US$) in Japan?
Give a very brief answer. -4.36e+06. In the year 1991, what is the difference between the Aid flow (current US$) in France and Aid flow (current US$) in Germany?
Your answer should be very brief. 8.16e+07. In the year 1991, what is the difference between the Aid flow (current US$) in France and Aid flow (current US$) in Italy?
Your response must be concise. 1.05e+08. In the year 1991, what is the difference between the Aid flow (current US$) in France and Aid flow (current US$) in Japan?
Keep it short and to the point. 9.99e+07. In the year 1991, what is the difference between the Aid flow (current US$) in Germany and Aid flow (current US$) in Italy?
Give a very brief answer. 2.32e+07. In the year 1991, what is the difference between the Aid flow (current US$) of Germany and Aid flow (current US$) of Japan?
Your response must be concise. 1.83e+07. In the year 1991, what is the difference between the Aid flow (current US$) in Italy and Aid flow (current US$) in Japan?
Ensure brevity in your answer.  -4.91e+06. In the year 1992, what is the difference between the Aid flow (current US$) in France and Aid flow (current US$) in Germany?
Offer a very short reply. 6.38e+07. In the year 1992, what is the difference between the Aid flow (current US$) in France and Aid flow (current US$) in Italy?
Keep it short and to the point. 9.73e+07. In the year 1992, what is the difference between the Aid flow (current US$) in France and Aid flow (current US$) in Japan?
Provide a succinct answer. 8.80e+07. In the year 1992, what is the difference between the Aid flow (current US$) in Germany and Aid flow (current US$) in Italy?
Ensure brevity in your answer.  3.35e+07. In the year 1992, what is the difference between the Aid flow (current US$) in Germany and Aid flow (current US$) in Japan?
Provide a succinct answer. 2.42e+07. In the year 1992, what is the difference between the Aid flow (current US$) of Italy and Aid flow (current US$) of Japan?
Provide a succinct answer. -9.22e+06. In the year 1993, what is the difference between the Aid flow (current US$) in France and Aid flow (current US$) in Germany?
Keep it short and to the point. 5.44e+07. In the year 1993, what is the difference between the Aid flow (current US$) of France and Aid flow (current US$) of Italy?
Offer a very short reply. 8.60e+07. In the year 1993, what is the difference between the Aid flow (current US$) in France and Aid flow (current US$) in Japan?
Your answer should be very brief. 7.37e+07. In the year 1993, what is the difference between the Aid flow (current US$) in Germany and Aid flow (current US$) in Italy?
Keep it short and to the point. 3.16e+07. In the year 1993, what is the difference between the Aid flow (current US$) in Germany and Aid flow (current US$) in Japan?
Your answer should be very brief. 1.93e+07. In the year 1993, what is the difference between the Aid flow (current US$) of Italy and Aid flow (current US$) of Japan?
Make the answer very short. -1.22e+07. In the year 1994, what is the difference between the Aid flow (current US$) of France and Aid flow (current US$) of Germany?
Your response must be concise. 1.02e+08. In the year 1994, what is the difference between the Aid flow (current US$) of France and Aid flow (current US$) of Italy?
Keep it short and to the point. 1.36e+08. In the year 1994, what is the difference between the Aid flow (current US$) in France and Aid flow (current US$) in Japan?
Ensure brevity in your answer.  1.23e+08. In the year 1994, what is the difference between the Aid flow (current US$) of Germany and Aid flow (current US$) of Italy?
Your response must be concise. 3.33e+07. In the year 1994, what is the difference between the Aid flow (current US$) of Germany and Aid flow (current US$) of Japan?
Your answer should be very brief. 2.05e+07. In the year 1994, what is the difference between the Aid flow (current US$) in Italy and Aid flow (current US$) in Japan?
Provide a short and direct response. -1.27e+07. In the year 1995, what is the difference between the Aid flow (current US$) of France and Aid flow (current US$) of Germany?
Your response must be concise. 2.69e+07. In the year 1995, what is the difference between the Aid flow (current US$) of France and Aid flow (current US$) of Italy?
Make the answer very short. 7.20e+07. In the year 1995, what is the difference between the Aid flow (current US$) of France and Aid flow (current US$) of Japan?
Make the answer very short. 5.98e+07. In the year 1995, what is the difference between the Aid flow (current US$) of Germany and Aid flow (current US$) of Italy?
Your answer should be very brief. 4.52e+07. In the year 1995, what is the difference between the Aid flow (current US$) of Germany and Aid flow (current US$) of Japan?
Give a very brief answer. 3.29e+07. In the year 1995, what is the difference between the Aid flow (current US$) in Italy and Aid flow (current US$) in Japan?
Your answer should be compact. -1.22e+07. In the year 1996, what is the difference between the Aid flow (current US$) of France and Aid flow (current US$) of Germany?
Offer a terse response. 5.95e+07. In the year 1996, what is the difference between the Aid flow (current US$) of France and Aid flow (current US$) of Italy?
Provide a succinct answer. 8.55e+07. In the year 1996, what is the difference between the Aid flow (current US$) of France and Aid flow (current US$) of Japan?
Your response must be concise. 7.28e+07. In the year 1996, what is the difference between the Aid flow (current US$) of Germany and Aid flow (current US$) of Italy?
Keep it short and to the point. 2.60e+07. In the year 1996, what is the difference between the Aid flow (current US$) in Germany and Aid flow (current US$) in Japan?
Offer a terse response. 1.32e+07. In the year 1996, what is the difference between the Aid flow (current US$) in Italy and Aid flow (current US$) in Japan?
Offer a terse response. -1.28e+07. What is the ratio of the Aid flow (current US$) of France in 1989 to that in 1990?
Offer a terse response. 0.75. What is the ratio of the Aid flow (current US$) of Germany in 1989 to that in 1990?
Provide a succinct answer. 0.83. What is the ratio of the Aid flow (current US$) in Italy in 1989 to that in 1990?
Make the answer very short. 0.4. What is the ratio of the Aid flow (current US$) of Japan in 1989 to that in 1990?
Keep it short and to the point. 1.2. What is the ratio of the Aid flow (current US$) of France in 1989 to that in 1991?
Ensure brevity in your answer.  0.52. What is the ratio of the Aid flow (current US$) of Germany in 1989 to that in 1991?
Your answer should be very brief. 0.6. What is the ratio of the Aid flow (current US$) in Italy in 1989 to that in 1991?
Provide a succinct answer. 0.26. What is the ratio of the Aid flow (current US$) of Japan in 1989 to that in 1991?
Offer a very short reply. 0.86. What is the ratio of the Aid flow (current US$) of France in 1989 to that in 1992?
Ensure brevity in your answer.  0.58. What is the ratio of the Aid flow (current US$) of Germany in 1989 to that in 1992?
Provide a succinct answer. 0.53. What is the ratio of the Aid flow (current US$) of Italy in 1989 to that in 1992?
Provide a succinct answer. 0.49. What is the ratio of the Aid flow (current US$) of Japan in 1989 to that in 1992?
Provide a short and direct response. 0.91. What is the ratio of the Aid flow (current US$) in France in 1989 to that in 1993?
Your answer should be very brief. 0.69. What is the ratio of the Aid flow (current US$) in Germany in 1989 to that in 1993?
Offer a terse response. 0.64. What is the ratio of the Aid flow (current US$) of Italy in 1989 to that in 1993?
Keep it short and to the point. 3.45. What is the ratio of the Aid flow (current US$) of Japan in 1989 to that in 1993?
Your answer should be very brief. 1.05. What is the ratio of the Aid flow (current US$) in France in 1989 to that in 1994?
Make the answer very short. 0.44. What is the ratio of the Aid flow (current US$) in Germany in 1989 to that in 1994?
Your response must be concise. 0.61. What is the ratio of the Aid flow (current US$) in Italy in 1989 to that in 1994?
Your answer should be very brief. 5.15. What is the ratio of the Aid flow (current US$) in Japan in 1989 to that in 1994?
Your answer should be very brief. 1.03. What is the ratio of the Aid flow (current US$) of France in 1989 to that in 1995?
Your answer should be compact. 0.82. What is the ratio of the Aid flow (current US$) of Germany in 1989 to that in 1995?
Provide a short and direct response. 0.44. What is the ratio of the Aid flow (current US$) of Italy in 1989 to that in 1995?
Your response must be concise. 2.01. What is the ratio of the Aid flow (current US$) in France in 1989 to that in 1996?
Offer a very short reply. 0.69. What is the ratio of the Aid flow (current US$) in Germany in 1989 to that in 1996?
Your answer should be very brief. 0.76. What is the ratio of the Aid flow (current US$) in Italy in 1989 to that in 1996?
Provide a succinct answer. 2.14. What is the ratio of the Aid flow (current US$) in Japan in 1989 to that in 1996?
Your answer should be compact. 0.97. What is the ratio of the Aid flow (current US$) in France in 1990 to that in 1991?
Your answer should be compact. 0.69. What is the ratio of the Aid flow (current US$) of Germany in 1990 to that in 1991?
Keep it short and to the point. 0.72. What is the ratio of the Aid flow (current US$) of Italy in 1990 to that in 1991?
Keep it short and to the point. 0.64. What is the ratio of the Aid flow (current US$) in Japan in 1990 to that in 1991?
Your answer should be compact. 0.71. What is the ratio of the Aid flow (current US$) in France in 1990 to that in 1992?
Offer a very short reply. 0.78. What is the ratio of the Aid flow (current US$) in Germany in 1990 to that in 1992?
Offer a very short reply. 0.63. What is the ratio of the Aid flow (current US$) of Italy in 1990 to that in 1992?
Offer a terse response. 1.2. What is the ratio of the Aid flow (current US$) of Japan in 1990 to that in 1992?
Keep it short and to the point. 0.76. What is the ratio of the Aid flow (current US$) of France in 1990 to that in 1993?
Offer a very short reply. 0.92. What is the ratio of the Aid flow (current US$) in Germany in 1990 to that in 1993?
Your answer should be very brief. 0.77. What is the ratio of the Aid flow (current US$) in Italy in 1990 to that in 1993?
Offer a very short reply. 8.54. What is the ratio of the Aid flow (current US$) of Japan in 1990 to that in 1993?
Offer a terse response. 0.87. What is the ratio of the Aid flow (current US$) in France in 1990 to that in 1994?
Ensure brevity in your answer.  0.59. What is the ratio of the Aid flow (current US$) in Germany in 1990 to that in 1994?
Provide a succinct answer. 0.73. What is the ratio of the Aid flow (current US$) in Italy in 1990 to that in 1994?
Your answer should be compact. 12.73. What is the ratio of the Aid flow (current US$) of Japan in 1990 to that in 1994?
Your response must be concise. 0.85. What is the ratio of the Aid flow (current US$) of France in 1990 to that in 1995?
Give a very brief answer. 1.09. What is the ratio of the Aid flow (current US$) of Germany in 1990 to that in 1995?
Offer a terse response. 0.53. What is the ratio of the Aid flow (current US$) in Italy in 1990 to that in 1995?
Your response must be concise. 4.96. What is the ratio of the Aid flow (current US$) in Japan in 1990 to that in 1995?
Provide a succinct answer. 0.83. What is the ratio of the Aid flow (current US$) of France in 1990 to that in 1996?
Your response must be concise. 0.92. What is the ratio of the Aid flow (current US$) in Germany in 1990 to that in 1996?
Your answer should be very brief. 0.91. What is the ratio of the Aid flow (current US$) in Italy in 1990 to that in 1996?
Offer a terse response. 5.3. What is the ratio of the Aid flow (current US$) of Japan in 1990 to that in 1996?
Your answer should be compact. 0.81. What is the ratio of the Aid flow (current US$) of France in 1991 to that in 1992?
Give a very brief answer. 1.12. What is the ratio of the Aid flow (current US$) of Germany in 1991 to that in 1992?
Provide a succinct answer. 0.87. What is the ratio of the Aid flow (current US$) of Italy in 1991 to that in 1992?
Provide a succinct answer. 1.9. What is the ratio of the Aid flow (current US$) of Japan in 1991 to that in 1992?
Offer a terse response. 1.06. What is the ratio of the Aid flow (current US$) in France in 1991 to that in 1993?
Provide a short and direct response. 1.33. What is the ratio of the Aid flow (current US$) of Germany in 1991 to that in 1993?
Ensure brevity in your answer.  1.06. What is the ratio of the Aid flow (current US$) of Italy in 1991 to that in 1993?
Keep it short and to the point. 13.44. What is the ratio of the Aid flow (current US$) in Japan in 1991 to that in 1993?
Keep it short and to the point. 1.22. What is the ratio of the Aid flow (current US$) in France in 1991 to that in 1994?
Give a very brief answer. 0.85. What is the ratio of the Aid flow (current US$) of Germany in 1991 to that in 1994?
Your answer should be compact. 1.01. What is the ratio of the Aid flow (current US$) of Italy in 1991 to that in 1994?
Your answer should be compact. 20.04. What is the ratio of the Aid flow (current US$) of Japan in 1991 to that in 1994?
Your answer should be very brief. 1.2. What is the ratio of the Aid flow (current US$) in France in 1991 to that in 1995?
Offer a very short reply. 1.58. What is the ratio of the Aid flow (current US$) in Germany in 1991 to that in 1995?
Keep it short and to the point. 0.74. What is the ratio of the Aid flow (current US$) of Italy in 1991 to that in 1995?
Provide a short and direct response. 7.82. What is the ratio of the Aid flow (current US$) in Japan in 1991 to that in 1995?
Give a very brief answer. 1.17. What is the ratio of the Aid flow (current US$) in France in 1991 to that in 1996?
Your response must be concise. 1.33. What is the ratio of the Aid flow (current US$) of Germany in 1991 to that in 1996?
Your answer should be very brief. 1.25. What is the ratio of the Aid flow (current US$) in Italy in 1991 to that in 1996?
Your answer should be very brief. 8.35. What is the ratio of the Aid flow (current US$) of Japan in 1991 to that in 1996?
Keep it short and to the point. 1.13. What is the ratio of the Aid flow (current US$) in France in 1992 to that in 1993?
Your response must be concise. 1.19. What is the ratio of the Aid flow (current US$) of Germany in 1992 to that in 1993?
Offer a terse response. 1.21. What is the ratio of the Aid flow (current US$) of Italy in 1992 to that in 1993?
Keep it short and to the point. 7.09. What is the ratio of the Aid flow (current US$) in Japan in 1992 to that in 1993?
Provide a short and direct response. 1.15. What is the ratio of the Aid flow (current US$) of France in 1992 to that in 1994?
Provide a succinct answer. 0.76. What is the ratio of the Aid flow (current US$) in Germany in 1992 to that in 1994?
Give a very brief answer. 1.16. What is the ratio of the Aid flow (current US$) of Italy in 1992 to that in 1994?
Ensure brevity in your answer.  10.56. What is the ratio of the Aid flow (current US$) of Japan in 1992 to that in 1994?
Your response must be concise. 1.13. What is the ratio of the Aid flow (current US$) of France in 1992 to that in 1995?
Your answer should be compact. 1.4. What is the ratio of the Aid flow (current US$) of Germany in 1992 to that in 1995?
Provide a short and direct response. 0.84. What is the ratio of the Aid flow (current US$) of Italy in 1992 to that in 1995?
Your response must be concise. 4.12. What is the ratio of the Aid flow (current US$) of Japan in 1992 to that in 1995?
Make the answer very short. 1.1. What is the ratio of the Aid flow (current US$) in France in 1992 to that in 1996?
Offer a terse response. 1.19. What is the ratio of the Aid flow (current US$) in Germany in 1992 to that in 1996?
Your answer should be very brief. 1.44. What is the ratio of the Aid flow (current US$) in Italy in 1992 to that in 1996?
Your response must be concise. 4.4. What is the ratio of the Aid flow (current US$) in Japan in 1992 to that in 1996?
Provide a succinct answer. 1.07. What is the ratio of the Aid flow (current US$) of France in 1993 to that in 1994?
Your answer should be compact. 0.64. What is the ratio of the Aid flow (current US$) in Germany in 1993 to that in 1994?
Provide a short and direct response. 0.96. What is the ratio of the Aid flow (current US$) in Italy in 1993 to that in 1994?
Your answer should be compact. 1.49. What is the ratio of the Aid flow (current US$) of Japan in 1993 to that in 1994?
Make the answer very short. 0.98. What is the ratio of the Aid flow (current US$) in France in 1993 to that in 1995?
Your response must be concise. 1.18. What is the ratio of the Aid flow (current US$) of Germany in 1993 to that in 1995?
Give a very brief answer. 0.69. What is the ratio of the Aid flow (current US$) in Italy in 1993 to that in 1995?
Give a very brief answer. 0.58. What is the ratio of the Aid flow (current US$) in Japan in 1993 to that in 1995?
Offer a terse response. 0.95. What is the ratio of the Aid flow (current US$) in Germany in 1993 to that in 1996?
Your response must be concise. 1.19. What is the ratio of the Aid flow (current US$) in Italy in 1993 to that in 1996?
Offer a very short reply. 0.62. What is the ratio of the Aid flow (current US$) of Japan in 1993 to that in 1996?
Your answer should be very brief. 0.93. What is the ratio of the Aid flow (current US$) in France in 1994 to that in 1995?
Offer a very short reply. 1.85. What is the ratio of the Aid flow (current US$) of Germany in 1994 to that in 1995?
Make the answer very short. 0.73. What is the ratio of the Aid flow (current US$) of Italy in 1994 to that in 1995?
Your answer should be compact. 0.39. What is the ratio of the Aid flow (current US$) of Japan in 1994 to that in 1995?
Your response must be concise. 0.97. What is the ratio of the Aid flow (current US$) of France in 1994 to that in 1996?
Provide a short and direct response. 1.57. What is the ratio of the Aid flow (current US$) in Germany in 1994 to that in 1996?
Your answer should be very brief. 1.24. What is the ratio of the Aid flow (current US$) of Italy in 1994 to that in 1996?
Provide a short and direct response. 0.42. What is the ratio of the Aid flow (current US$) in Japan in 1994 to that in 1996?
Your response must be concise. 0.94. What is the ratio of the Aid flow (current US$) in France in 1995 to that in 1996?
Your response must be concise. 0.85. What is the ratio of the Aid flow (current US$) in Germany in 1995 to that in 1996?
Offer a terse response. 1.71. What is the ratio of the Aid flow (current US$) in Italy in 1995 to that in 1996?
Your answer should be compact. 1.07. What is the ratio of the Aid flow (current US$) in Japan in 1995 to that in 1996?
Your answer should be very brief. 0.97. What is the difference between the highest and the second highest Aid flow (current US$) of France?
Provide a succinct answer. 2.02e+07. What is the difference between the highest and the second highest Aid flow (current US$) of Germany?
Offer a very short reply. 7.31e+06. What is the difference between the highest and the second highest Aid flow (current US$) of Italy?
Keep it short and to the point. 4.02e+06. What is the difference between the highest and the lowest Aid flow (current US$) of France?
Provide a succinct answer. 7.58e+07. What is the difference between the highest and the lowest Aid flow (current US$) in Germany?
Offer a very short reply. 2.59e+07. What is the difference between the highest and the lowest Aid flow (current US$) in Italy?
Provide a succinct answer. 1.05e+07. What is the difference between the highest and the lowest Aid flow (current US$) in Japan?
Keep it short and to the point. 4.57e+06. 